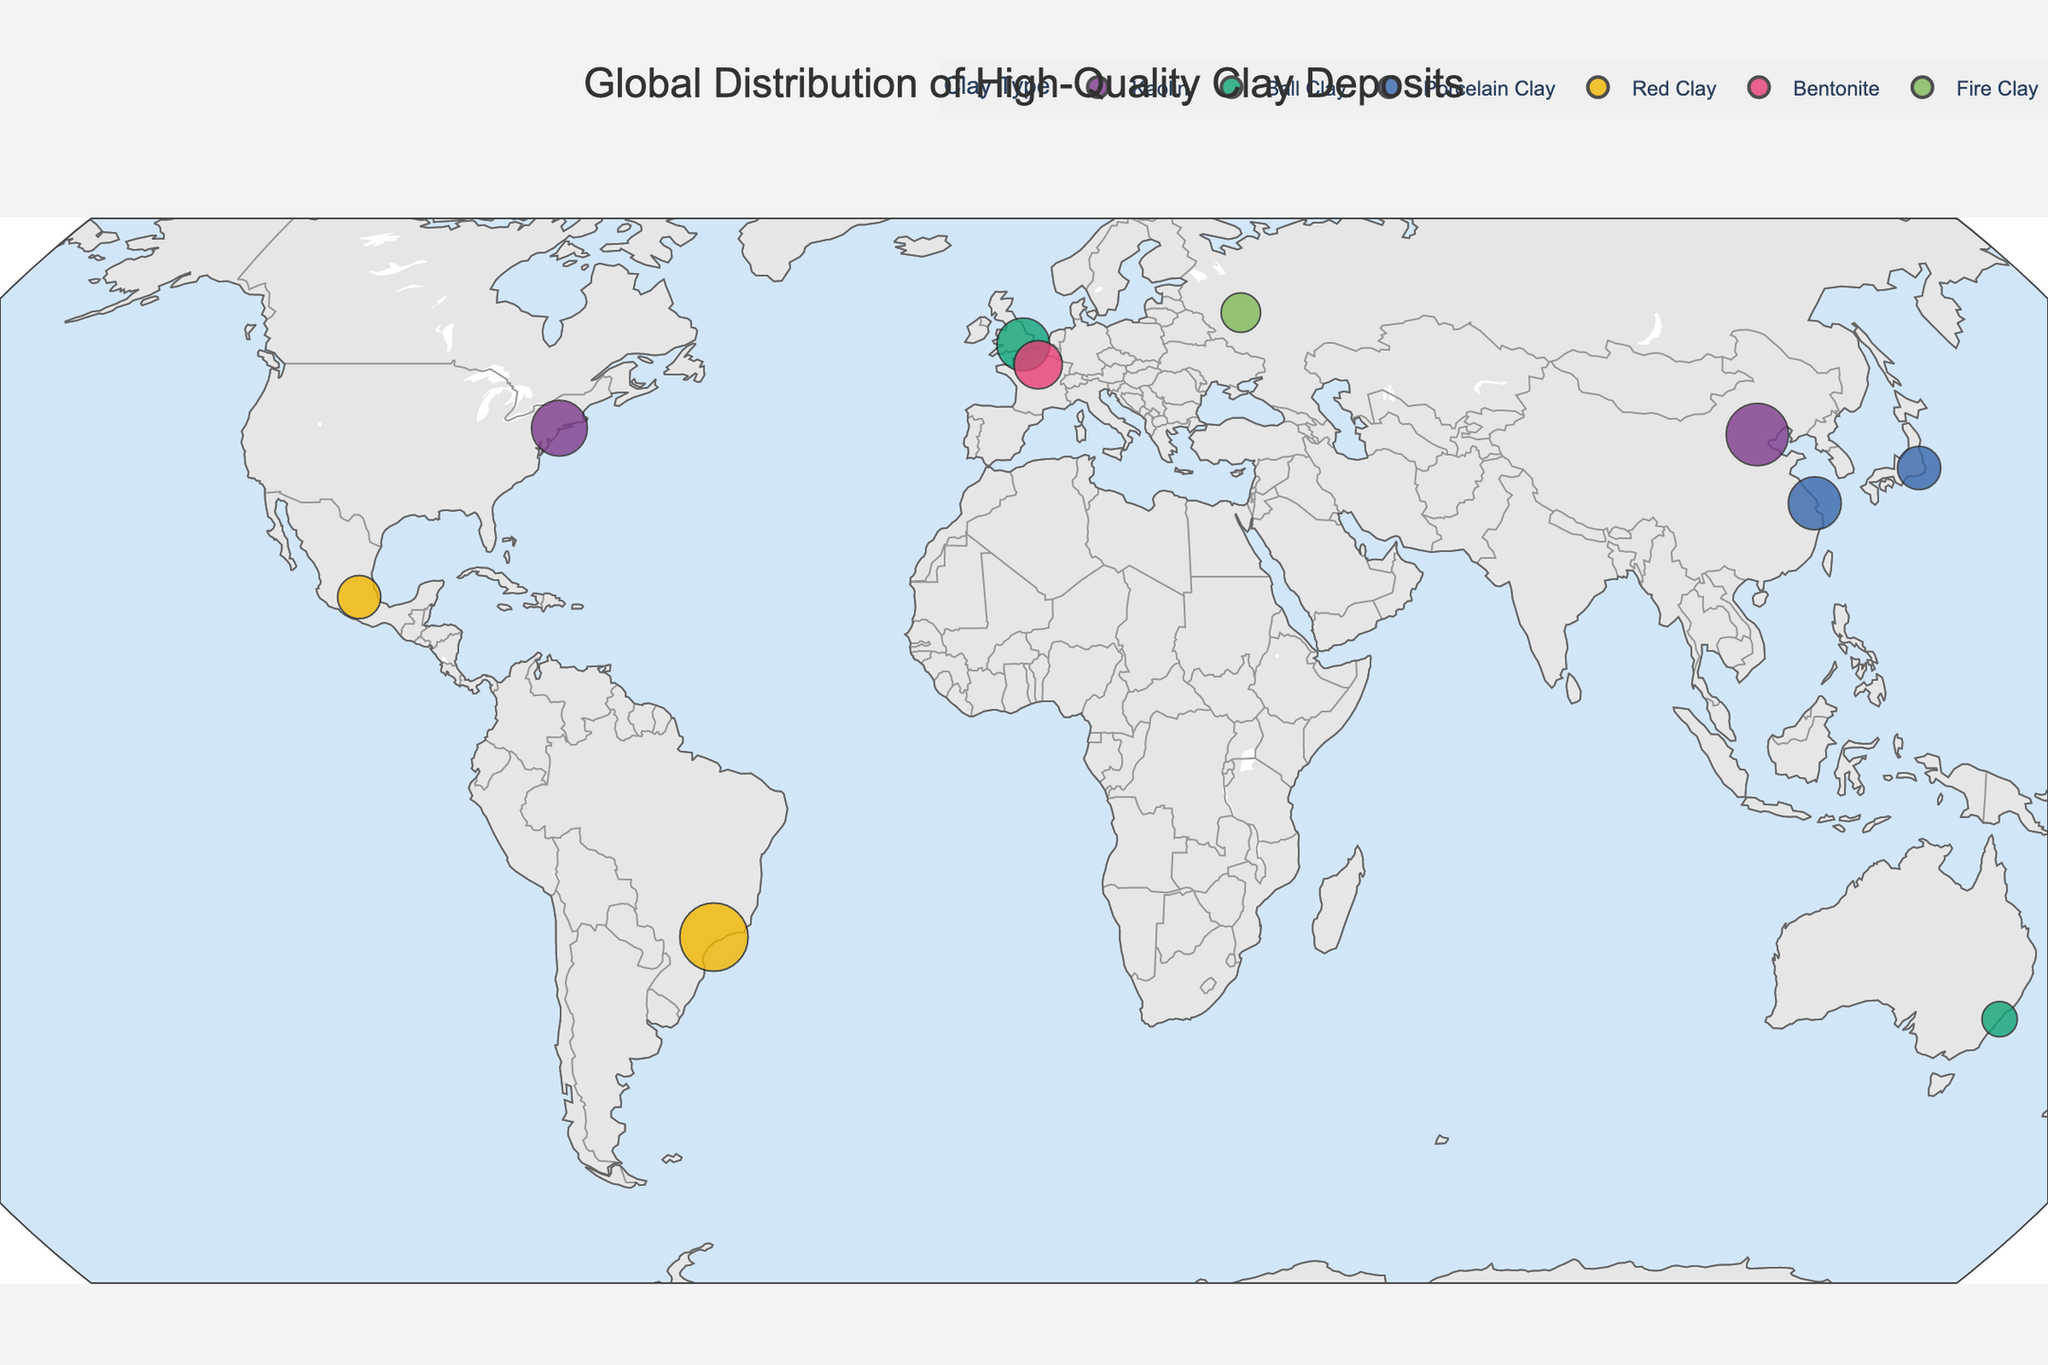What's the title of the plot? The title of the plot is shown at the top center of the figure. It reads "Global Distribution of High-Quality Clay Deposits."
Answer: Global Distribution of High-Quality Clay Deposits Which location has the highest annual production of clay? Each location's annual production is represented by the size of the marker on the map. The larger the marker, the higher the production. The largest marker is observed in Sao Paulo, Brazil, which indicates the highest annual production.
Answer: Sao Paulo, Brazil How many types of clay are shown on the map? Different types of clay are differentiated by colors on the map. By examining the legend, you can count the distinct clay types represented. There are five types of clay listed in the legend.
Answer: 5 Which locations in the figure are known for Kaolin clay? By referring to the color key and legend for Kaolin clay, you can identify the corresponding markers on the map. The locations marked with Kaolin clay are Yixian Formation (China) and Georgia (USA).
Answer: Yixian Formation (China), Georgia (USA) Compare the annual production of clay between Yixian Formation in China and Amakusa in Japan. Which one is higher and by how much? The annual production is given in the tooltip information. Yixian Formation in China has 2,500,000 tons, while Amakusa in Japan has 1,200,000 tons. Subtracting the two gives the amount by which Yixian Formation is higher: 2,500,000 - 1,200,000 = 1,300,000 tons.
Answer: Yixian Formation is higher by 1,300,000 tons Which location has the highest quality rating and what type of clay does it produce? Quality ratings are provided in the tooltip for each location. The highest quality rating of 9 is seen in Yixian Formation, China (Kaolin), Amakusa, Japan (Porcelain Clay), and New South Wales, Australia (Ball Clay).
Answer: Yixian Formation (Kaolin), Amakusa (Porcelain Clay), New South Wales (Ball Clay) What is the key characteristic of the clay found in the Ural Mountains, Russia? The tooltip provides information on key characteristics. For the Ural Mountains, Russia, it mentions "High heat resistance low impurities."
Answer: High heat resistance low impurities Which location has both high plasticity and good fired strength? Key characteristics are provided in tooltips. By examining these details, you find that Ball Clay in the UK has both "High plasticity good fired strength."
Answer: UK If you combine the annual production of the Red Clay locations in Brazil and Mexico, what is the total production? The annual production of Red Clay in Sao Paulo, Brazil, is 3,000,000 tons, and in Oaxaca, Mexico, it is 1,200,000 tons. Summing these gives the total production: 3,000,000 + 1,200,000 = 4,200,000 tons.
Answer: 4,200,000 tons Identify two locations with Porcelain Clay and their respective quality ratings. By referencing the legend and corresponding markers, the two locations with Porcelain Clay are Amakusa, Japan (Quality Rating 9) and Suzhou, China (Quality Rating 8).
Answer: Amakusa (9), Suzhou (8) 